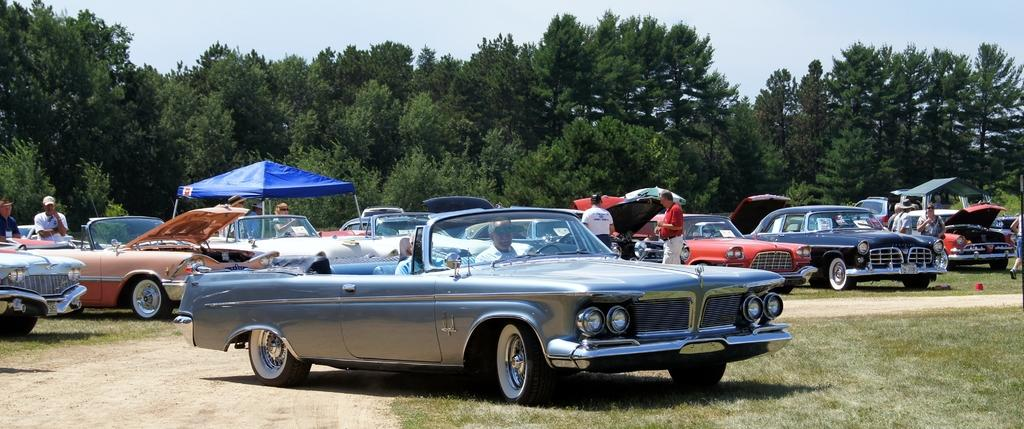What is located in the foreground of the image? There are cars and persons in the foreground of the image. What can be seen in the middle of the image? There are trees in the middle of the image. What is visible at the top of the image? The sky is visible at the top of the image. Can you tell me where the river is located in the image? There is no river present in the image. What type of book is being read by the person in the image? There is no book visible in the image. 